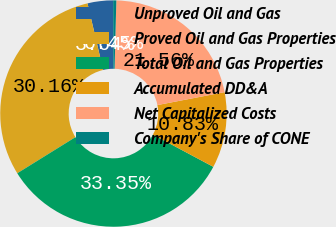Convert chart to OTSL. <chart><loc_0><loc_0><loc_500><loc_500><pie_chart><fcel>Unproved Oil and Gas<fcel>Proved Oil and Gas Properties<fcel>Total Oil and Gas Properties<fcel>Accumulated DD&A<fcel>Net Capitalized Costs<fcel>Company's Share of CONE<nl><fcel>3.64%<fcel>30.16%<fcel>33.35%<fcel>10.83%<fcel>21.56%<fcel>0.45%<nl></chart> 